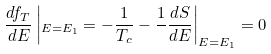<formula> <loc_0><loc_0><loc_500><loc_500>\frac { d f _ { T } } { d E } \left | _ { E = E _ { 1 } } = - \frac { 1 } { T _ { c } } - \frac { 1 } { } \frac { d S } { d E } \right | _ { E = E _ { 1 } } = 0</formula> 